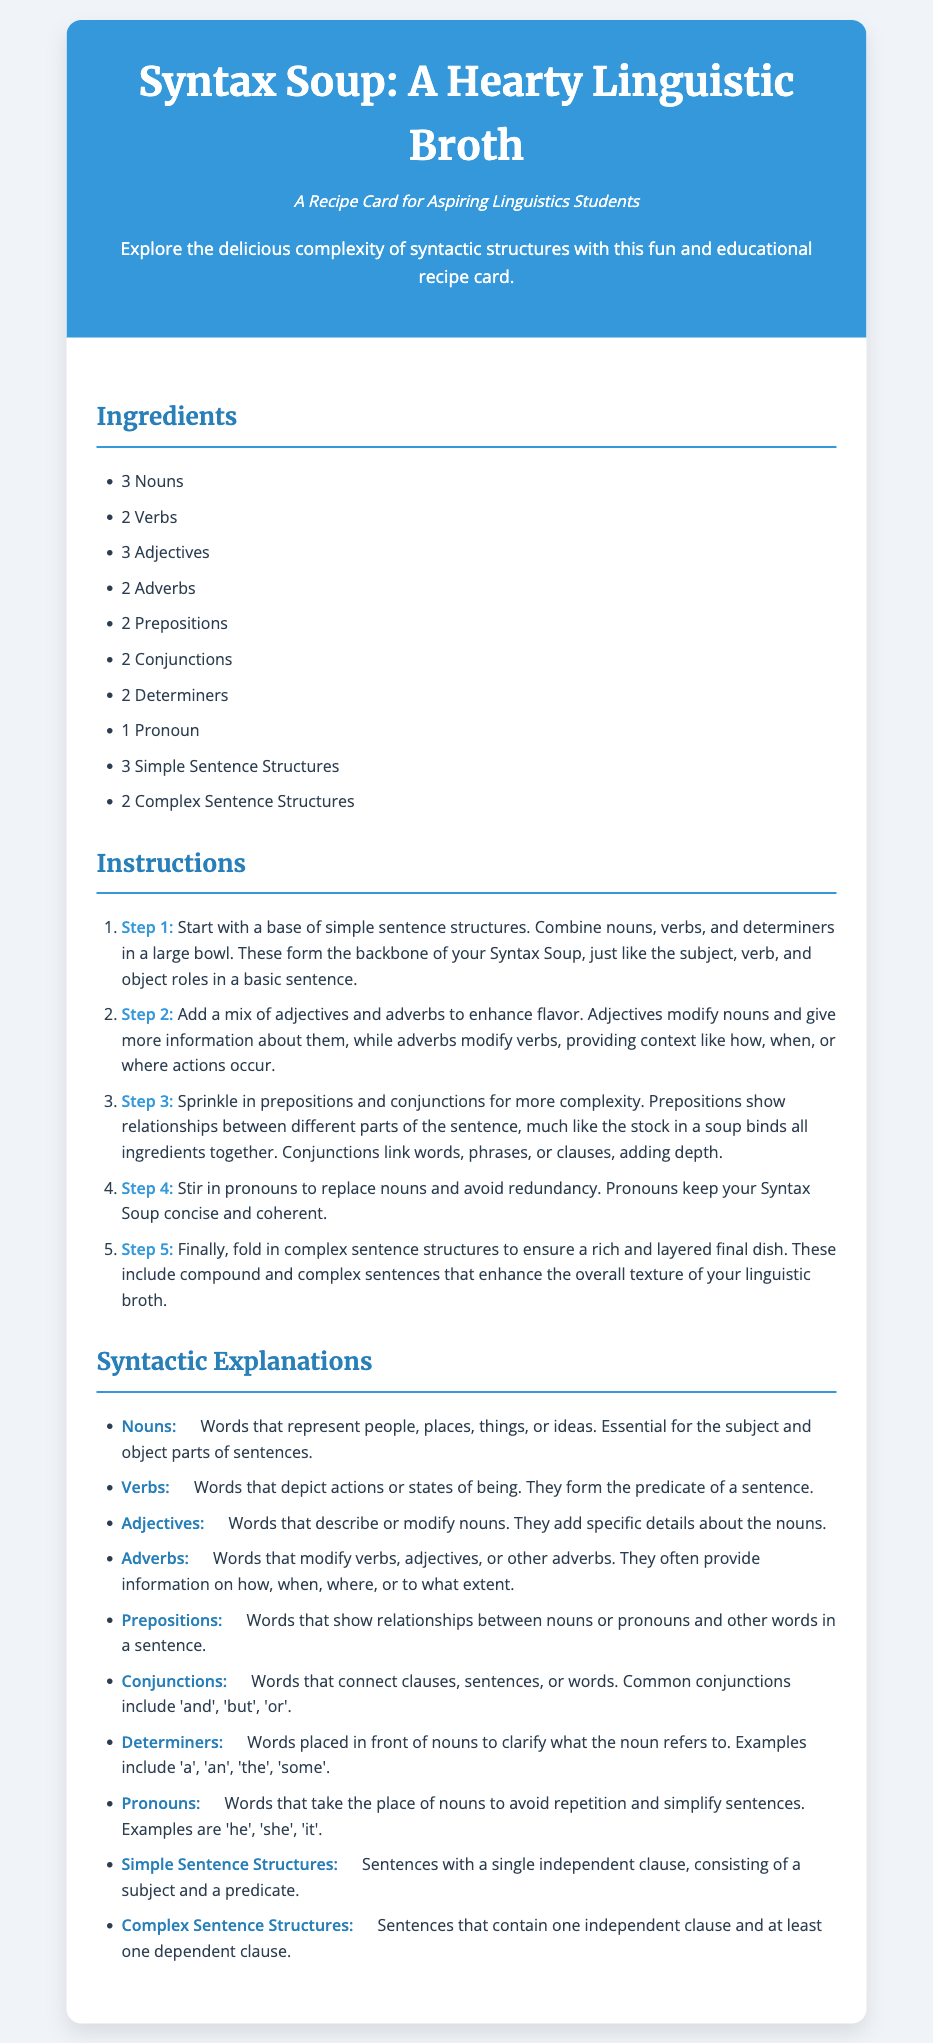What is the title of the recipe? The title of the recipe is prominently displayed at the top of the document.
Answer: Syntax Soup: A Hearty Linguistic Broth How many nouns are required for the recipe? The number of nouns can be found in the ingredients section of the document.
Answer: 3 Nouns What step involves adding adjectives and adverbs? The step number for adding adjectives and adverbs is included in a numbered list in the instructions.
Answer: Step 2 What types of sentence structures are included in the ingredients? The ingredients section lists different types of sentence structures.
Answer: 3 Simple Sentence Structures, 2 Complex Sentence Structures What is the definition of conjunctions? The definition of conjunctions is found in the syntactic explanations section.
Answer: Words that connect clauses, sentences, or words In which step do you fold in complex sentence structures? This step is specified in the instructions as one of the numbered steps to follow.
Answer: Step 5 What are the two components that enhance the flavor in Step 2? The two components that enhance flavor are mentioned in the context of adding ingredients in that step.
Answer: Adjectives and adverbs How many total steps are provided in the instructions? The total number of steps can be counted in the instructions list provided in the document.
Answer: 5 Steps 